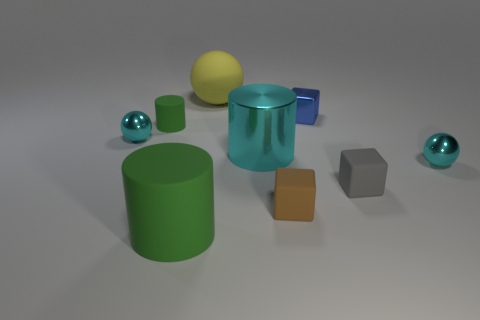Add 1 small green matte cylinders. How many objects exist? 10 Subtract all cylinders. How many objects are left? 6 Subtract 1 cyan cylinders. How many objects are left? 8 Subtract all tiny green matte cylinders. Subtract all gray things. How many objects are left? 7 Add 7 big green matte cylinders. How many big green matte cylinders are left? 8 Add 5 blue metallic things. How many blue metallic things exist? 6 